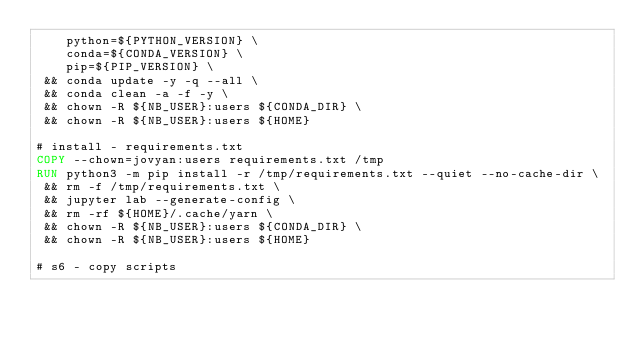Convert code to text. <code><loc_0><loc_0><loc_500><loc_500><_Dockerfile_>    python=${PYTHON_VERSION} \
    conda=${CONDA_VERSION} \
    pip=${PIP_VERSION} \
 && conda update -y -q --all \
 && conda clean -a -f -y \
 && chown -R ${NB_USER}:users ${CONDA_DIR} \
 && chown -R ${NB_USER}:users ${HOME}

# install - requirements.txt
COPY --chown=jovyan:users requirements.txt /tmp
RUN python3 -m pip install -r /tmp/requirements.txt --quiet --no-cache-dir \
 && rm -f /tmp/requirements.txt \
 && jupyter lab --generate-config \
 && rm -rf ${HOME}/.cache/yarn \
 && chown -R ${NB_USER}:users ${CONDA_DIR} \
 && chown -R ${NB_USER}:users ${HOME}

# s6 - copy scripts</code> 